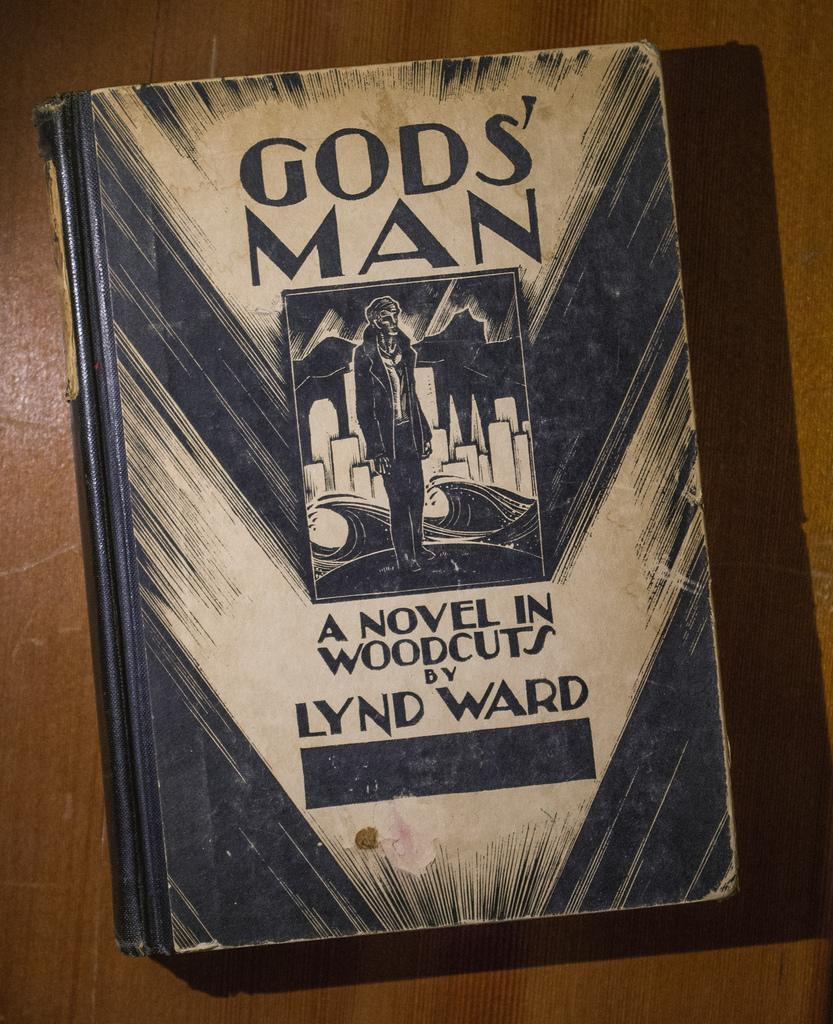<image>
Offer a succinct explanation of the picture presented. A book by the title of Gos' Man 